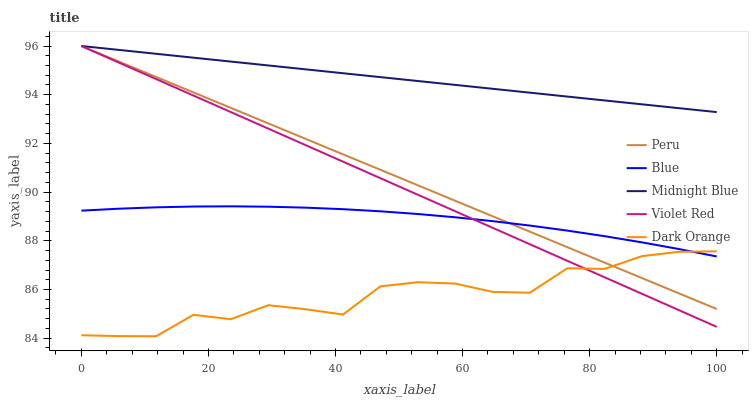Does Dark Orange have the minimum area under the curve?
Answer yes or no. Yes. Does Midnight Blue have the maximum area under the curve?
Answer yes or no. Yes. Does Violet Red have the minimum area under the curve?
Answer yes or no. No. Does Violet Red have the maximum area under the curve?
Answer yes or no. No. Is Peru the smoothest?
Answer yes or no. Yes. Is Dark Orange the roughest?
Answer yes or no. Yes. Is Violet Red the smoothest?
Answer yes or no. No. Is Violet Red the roughest?
Answer yes or no. No. Does Dark Orange have the lowest value?
Answer yes or no. Yes. Does Violet Red have the lowest value?
Answer yes or no. No. Does Peru have the highest value?
Answer yes or no. Yes. Does Dark Orange have the highest value?
Answer yes or no. No. Is Blue less than Midnight Blue?
Answer yes or no. Yes. Is Midnight Blue greater than Blue?
Answer yes or no. Yes. Does Blue intersect Dark Orange?
Answer yes or no. Yes. Is Blue less than Dark Orange?
Answer yes or no. No. Is Blue greater than Dark Orange?
Answer yes or no. No. Does Blue intersect Midnight Blue?
Answer yes or no. No. 